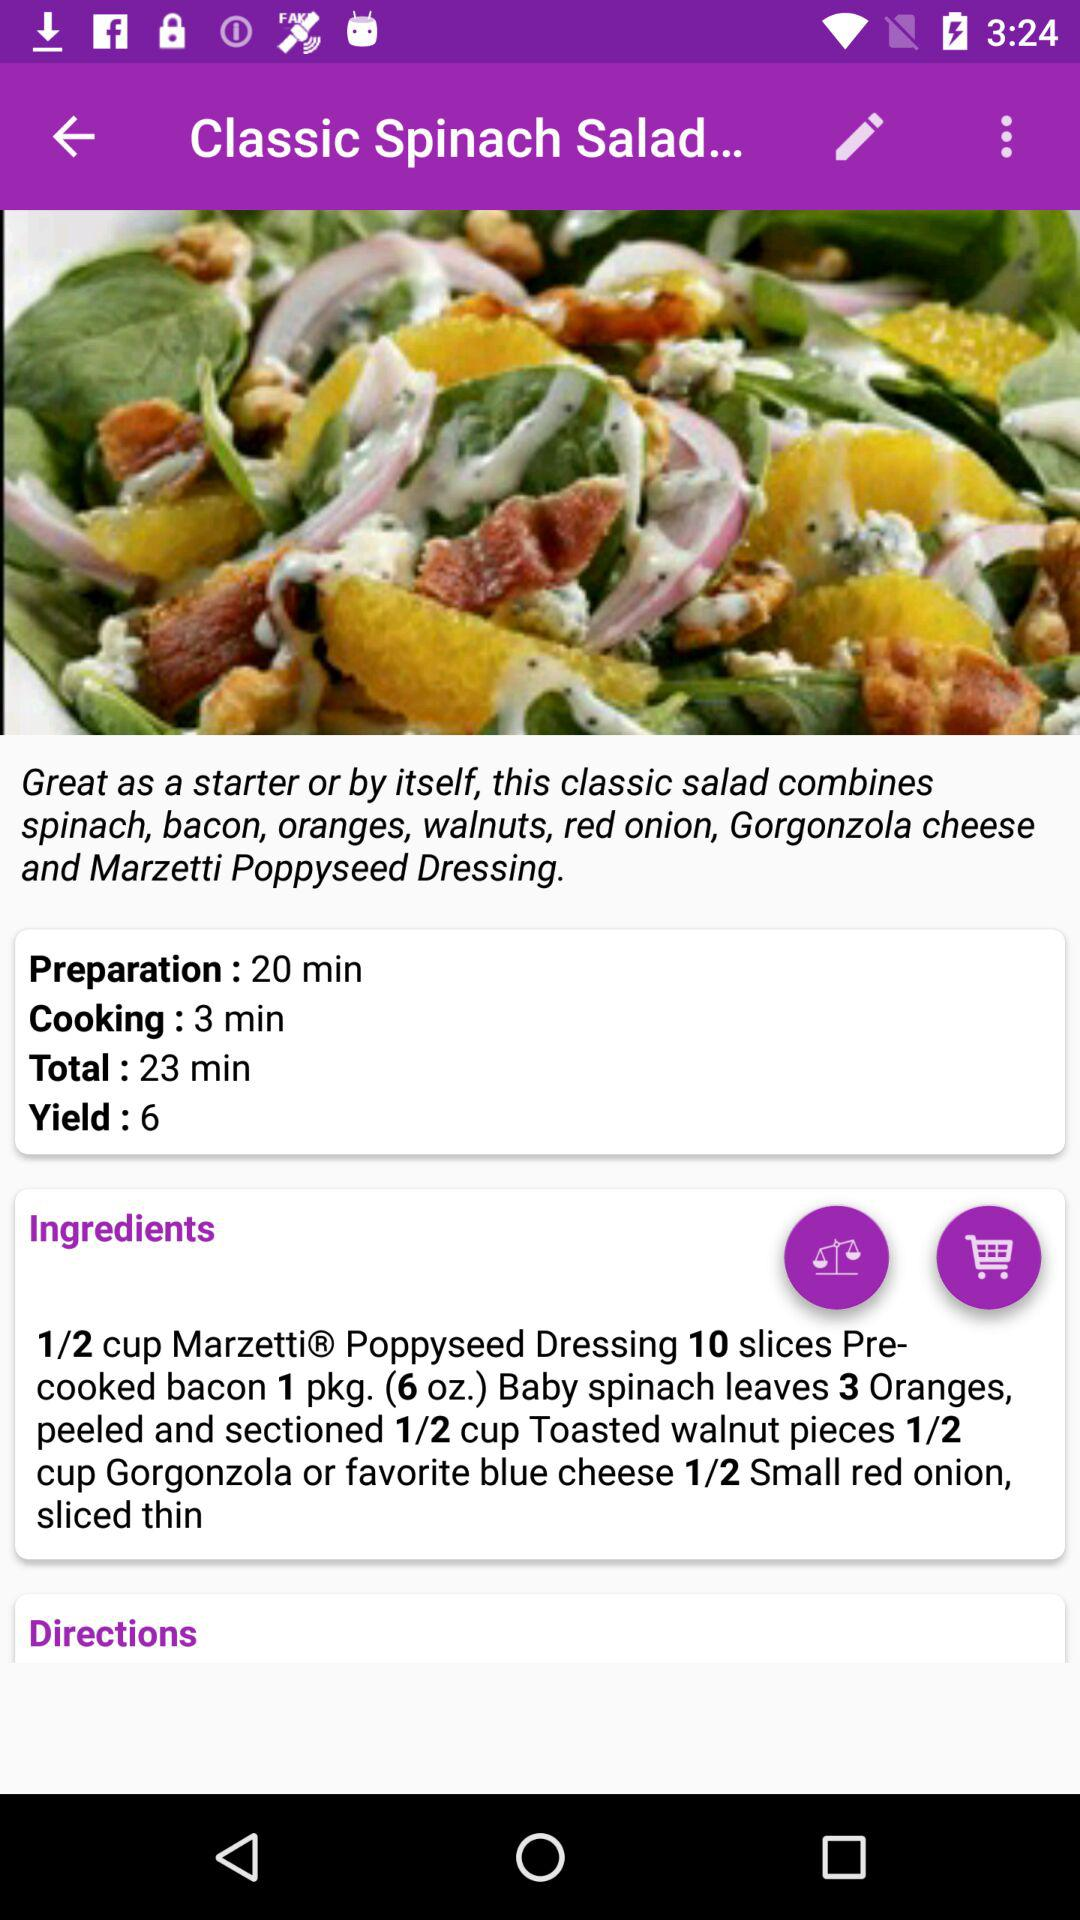How many red onions are required? There is 1/2 small red onion required. 